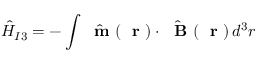Convert formula to latex. <formula><loc_0><loc_0><loc_500><loc_500>\hat { H } _ { I 3 } = - \int \hat { m } ( r ) \cdot \hat { B } ( r ) \, d ^ { 3 } r</formula> 